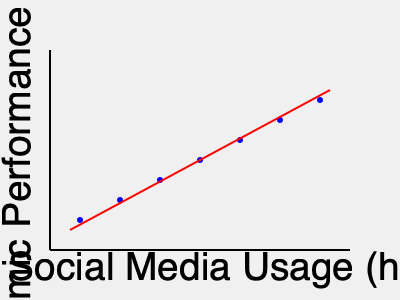Based on the scatter plot, what can be inferred about the relationship between daily social media usage and academic performance (GPA) among students? To interpret the scatter plot and determine the relationship between daily social media usage and academic performance, we need to follow these steps:

1. Identify the variables:
   - X-axis: Daily Social Media Usage (hours)
   - Y-axis: Academic Performance (GPA)

2. Observe the pattern of data points:
   - The points form a downward sloping pattern from left to right.

3. Analyze the trend:
   - As we move from left to right (increasing social media usage), the points tend to move downward (decreasing GPA).

4. Interpret the relationship:
   - This pattern suggests a negative correlation between social media usage and academic performance.

5. Consider the strength of the relationship:
   - The points are relatively close to the trend line, indicating a moderately strong correlation.

6. Draw a conclusion:
   - As daily social media usage increases, academic performance tends to decrease.

Given this analysis, we can infer that there is a negative correlation between daily social media usage and academic performance among students. This means that students who spend more time on social media tend to have lower GPAs, while those who spend less time on social media tend to have higher GPAs.
Answer: Negative correlation: As social media usage increases, academic performance tends to decrease. 